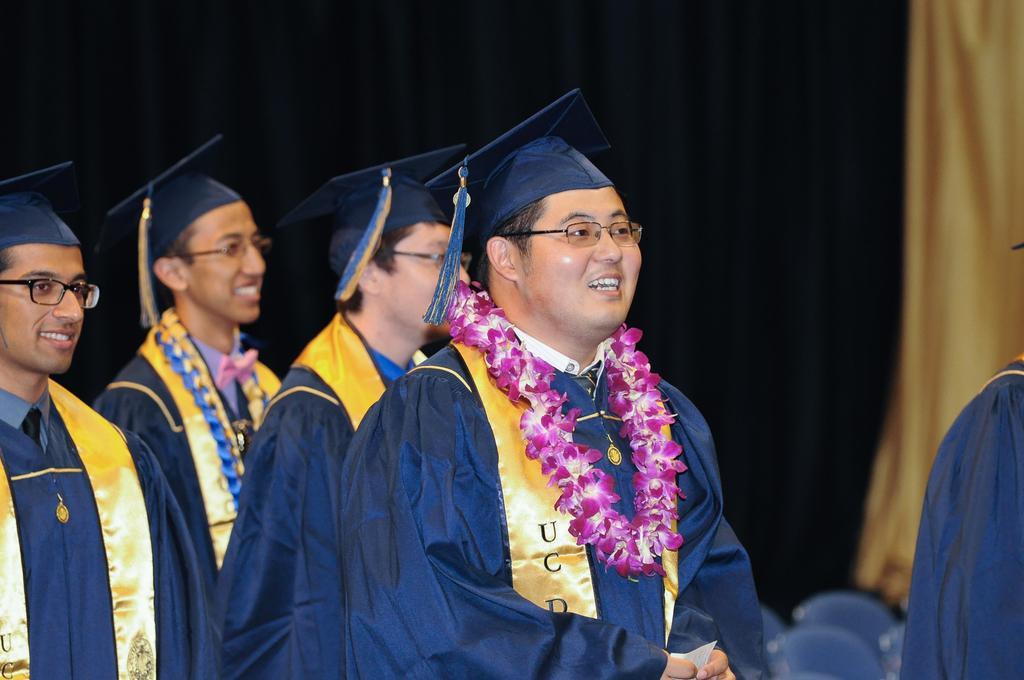Can you describe this image briefly? In this image we can see group of people standing. In that a person wearing a garland is holding a paper with his hands. On the backside we can see some curtains. 